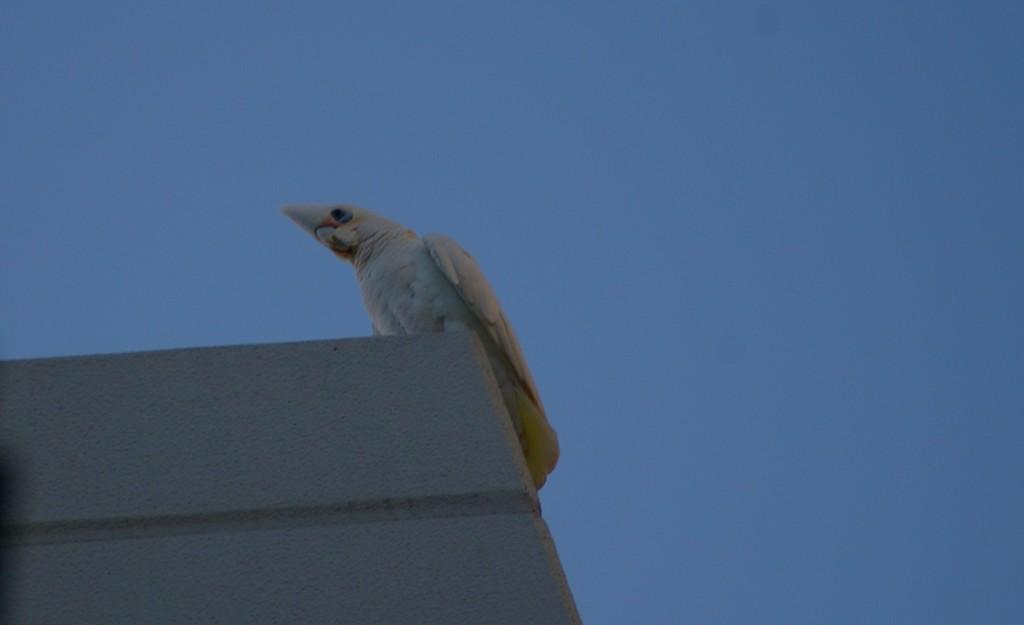Could you give a brief overview of what you see in this image? In this image I can see the bird on the white color object. The bird is in white color. In the background I can see the blue sky. 